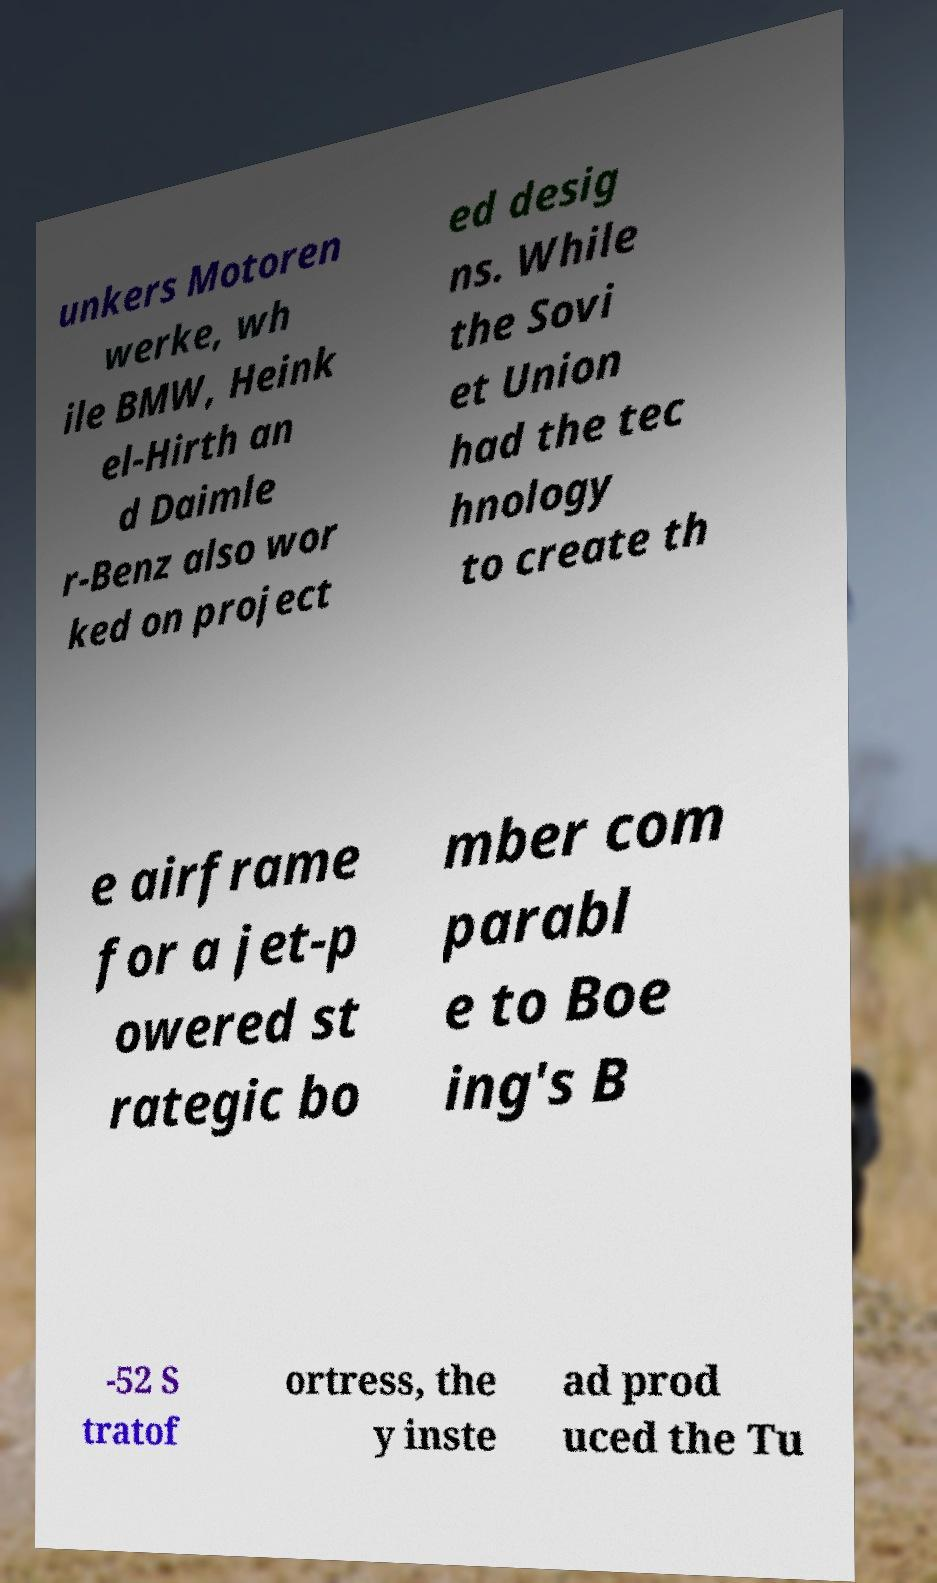Please identify and transcribe the text found in this image. unkers Motoren werke, wh ile BMW, Heink el-Hirth an d Daimle r-Benz also wor ked on project ed desig ns. While the Sovi et Union had the tec hnology to create th e airframe for a jet-p owered st rategic bo mber com parabl e to Boe ing's B -52 S tratof ortress, the y inste ad prod uced the Tu 